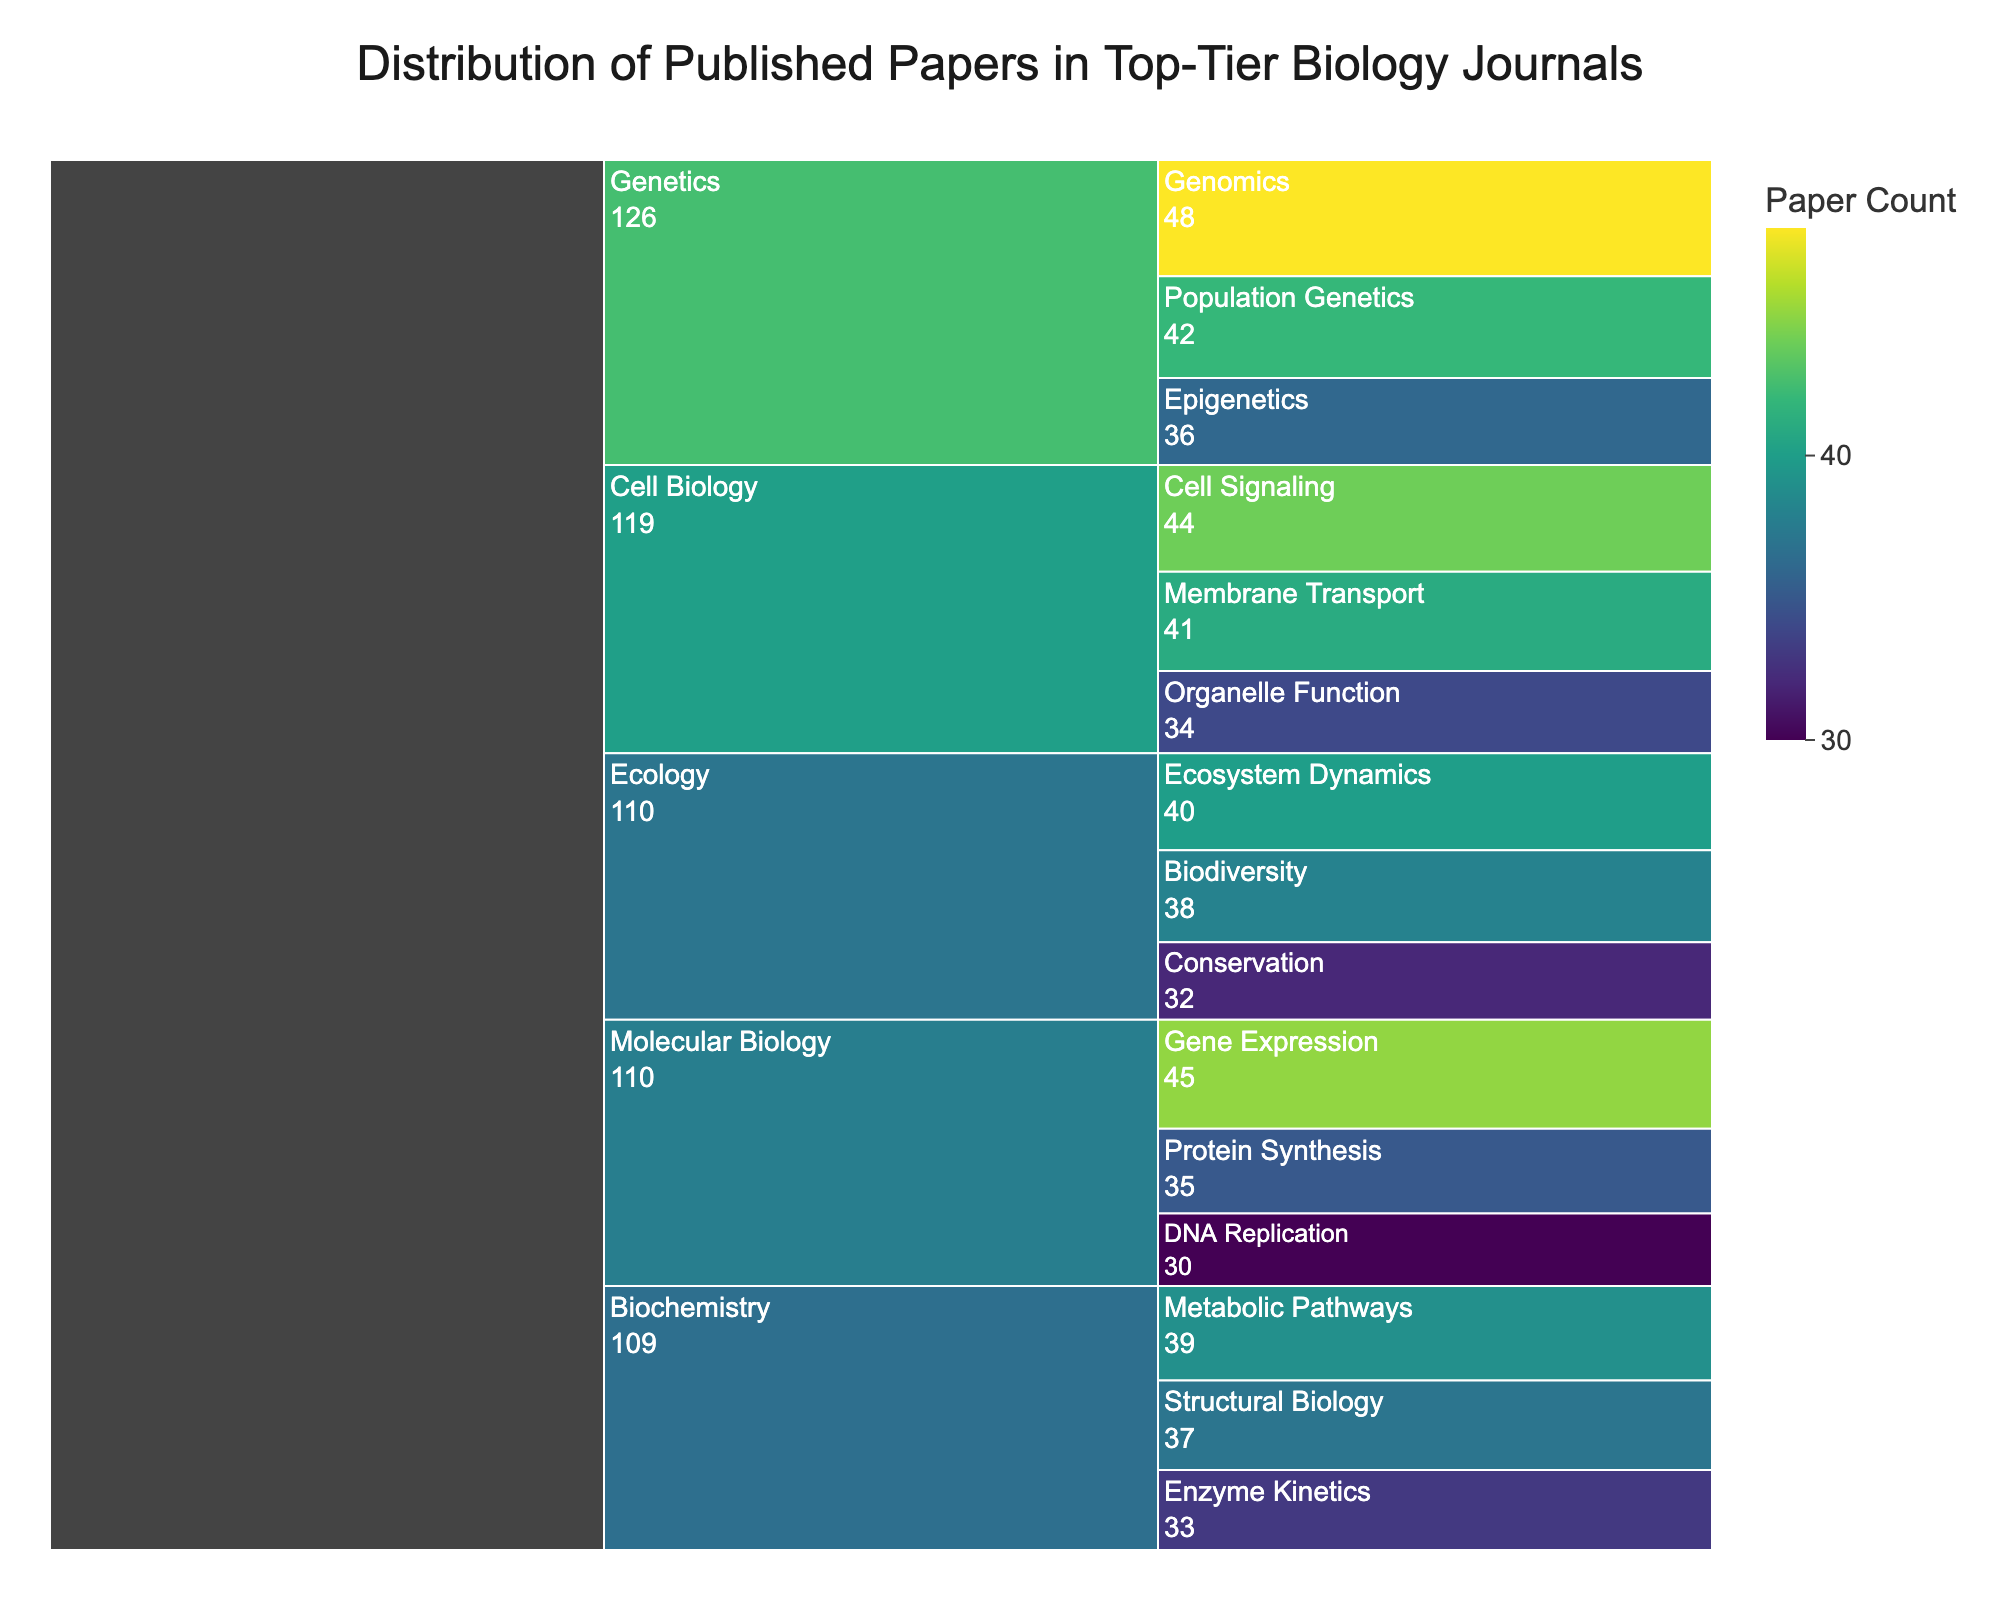What's the total number of published papers in Molecular Biology? To find the total number of published papers in Molecular Biology, sum up the counts of its subcategories: Gene Expression (45), DNA Replication (30), and Protein Synthesis (35). Therefore, 45 + 30 + 35 = 110.
Answer: 110 Which category has the highest number of published papers? To determine which category has the highest number of published papers, examine the root nodes of each branch and compare their summed values. Genetics has Population Genetics (42), Epigenetics (36), and Genomics (48), totaling 126, which is the highest.
Answer: Genetics Compare the number of papers in Ecosystem Dynamics and Protein Synthesis. Which one has more? Look at the values for Ecosystem Dynamics (40) and Protein Synthesis (35). Since 40 is greater than 35, Ecosystem Dynamics has more papers.
Answer: Ecosystem Dynamics What's the average number of published papers per subcategory in Ecology? There are three subcategories in Ecology: Ecosystem Dynamics (40), Biodiversity (38), and Conservation (32). To find the average, sum these counts and divide by the number of subcategories: (40 + 38 + 32) / 3 = 110 / 3 ≈ 36.67.
Answer: 36.67 Which subcategory has the lowest number of published papers? Identify the smallest value in the subcategories’ leaf nodes. DNA Replication in Molecular Biology has 30, which is the lowest.
Answer: DNA Replication Rank the categories by the number of total published papers from highest to lowest. To rank the categories, sum the counts of subcategories in each and compare:
- Genetics: 42 + 36 + 48 = 126
- Molecular Biology: 45 + 30 + 35 = 110
- Ecology: 40 + 38 + 32 = 110
- Cell Biology: 41 + 44 + 34 = 119
- Biochemistry: 39 + 33 + 37 = 109
So, the ranking is Genetics > Cell Biology > Molecular Biology = Ecology > Biochemistry.
Answer: Genetics, Cell Biology, Molecular Biology = Ecology, Biochemistry How does the number of papers in Metabolic Pathways compare to those in Protein Synthesis? Compare the values for Metabolic Pathways (39) and Protein Synthesis (35). Since 39 is greater than 35, Metabolic Pathways has more papers.
Answer: Metabolic Pathways What is the overall number of published papers represented in the chart? Sum the counts of all subcategories: 45 + 30 + 35 + 40 + 38 + 32 + 42 + 36 + 48 + 39 + 33 + 37 + 41 + 44 + 34 = 574.
Answer: 574 